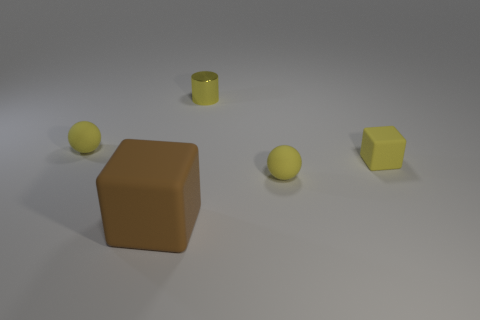The cylinder that is the same color as the tiny rubber block is what size?
Offer a very short reply. Small. What number of objects are the same color as the small cylinder?
Provide a short and direct response. 3. Are there any other things that have the same color as the cylinder?
Make the answer very short. Yes. How many cubes are either tiny red metallic things or small yellow metallic things?
Offer a very short reply. 0. What number of yellow rubber spheres are both on the right side of the metal cylinder and left of the big brown object?
Ensure brevity in your answer.  0. Is the number of yellow rubber blocks that are on the left side of the large brown cube the same as the number of brown objects that are behind the yellow shiny cylinder?
Provide a succinct answer. Yes. There is a small yellow object that is on the left side of the large thing; is its shape the same as the metal object?
Offer a very short reply. No. There is a big rubber object in front of the tiny matte sphere that is on the left side of the tiny yellow metallic cylinder that is behind the large object; what shape is it?
Your answer should be compact. Cube. There is a shiny object that is the same color as the tiny cube; what shape is it?
Offer a terse response. Cylinder. There is a object that is both to the left of the shiny cylinder and behind the big thing; what material is it?
Make the answer very short. Rubber. 